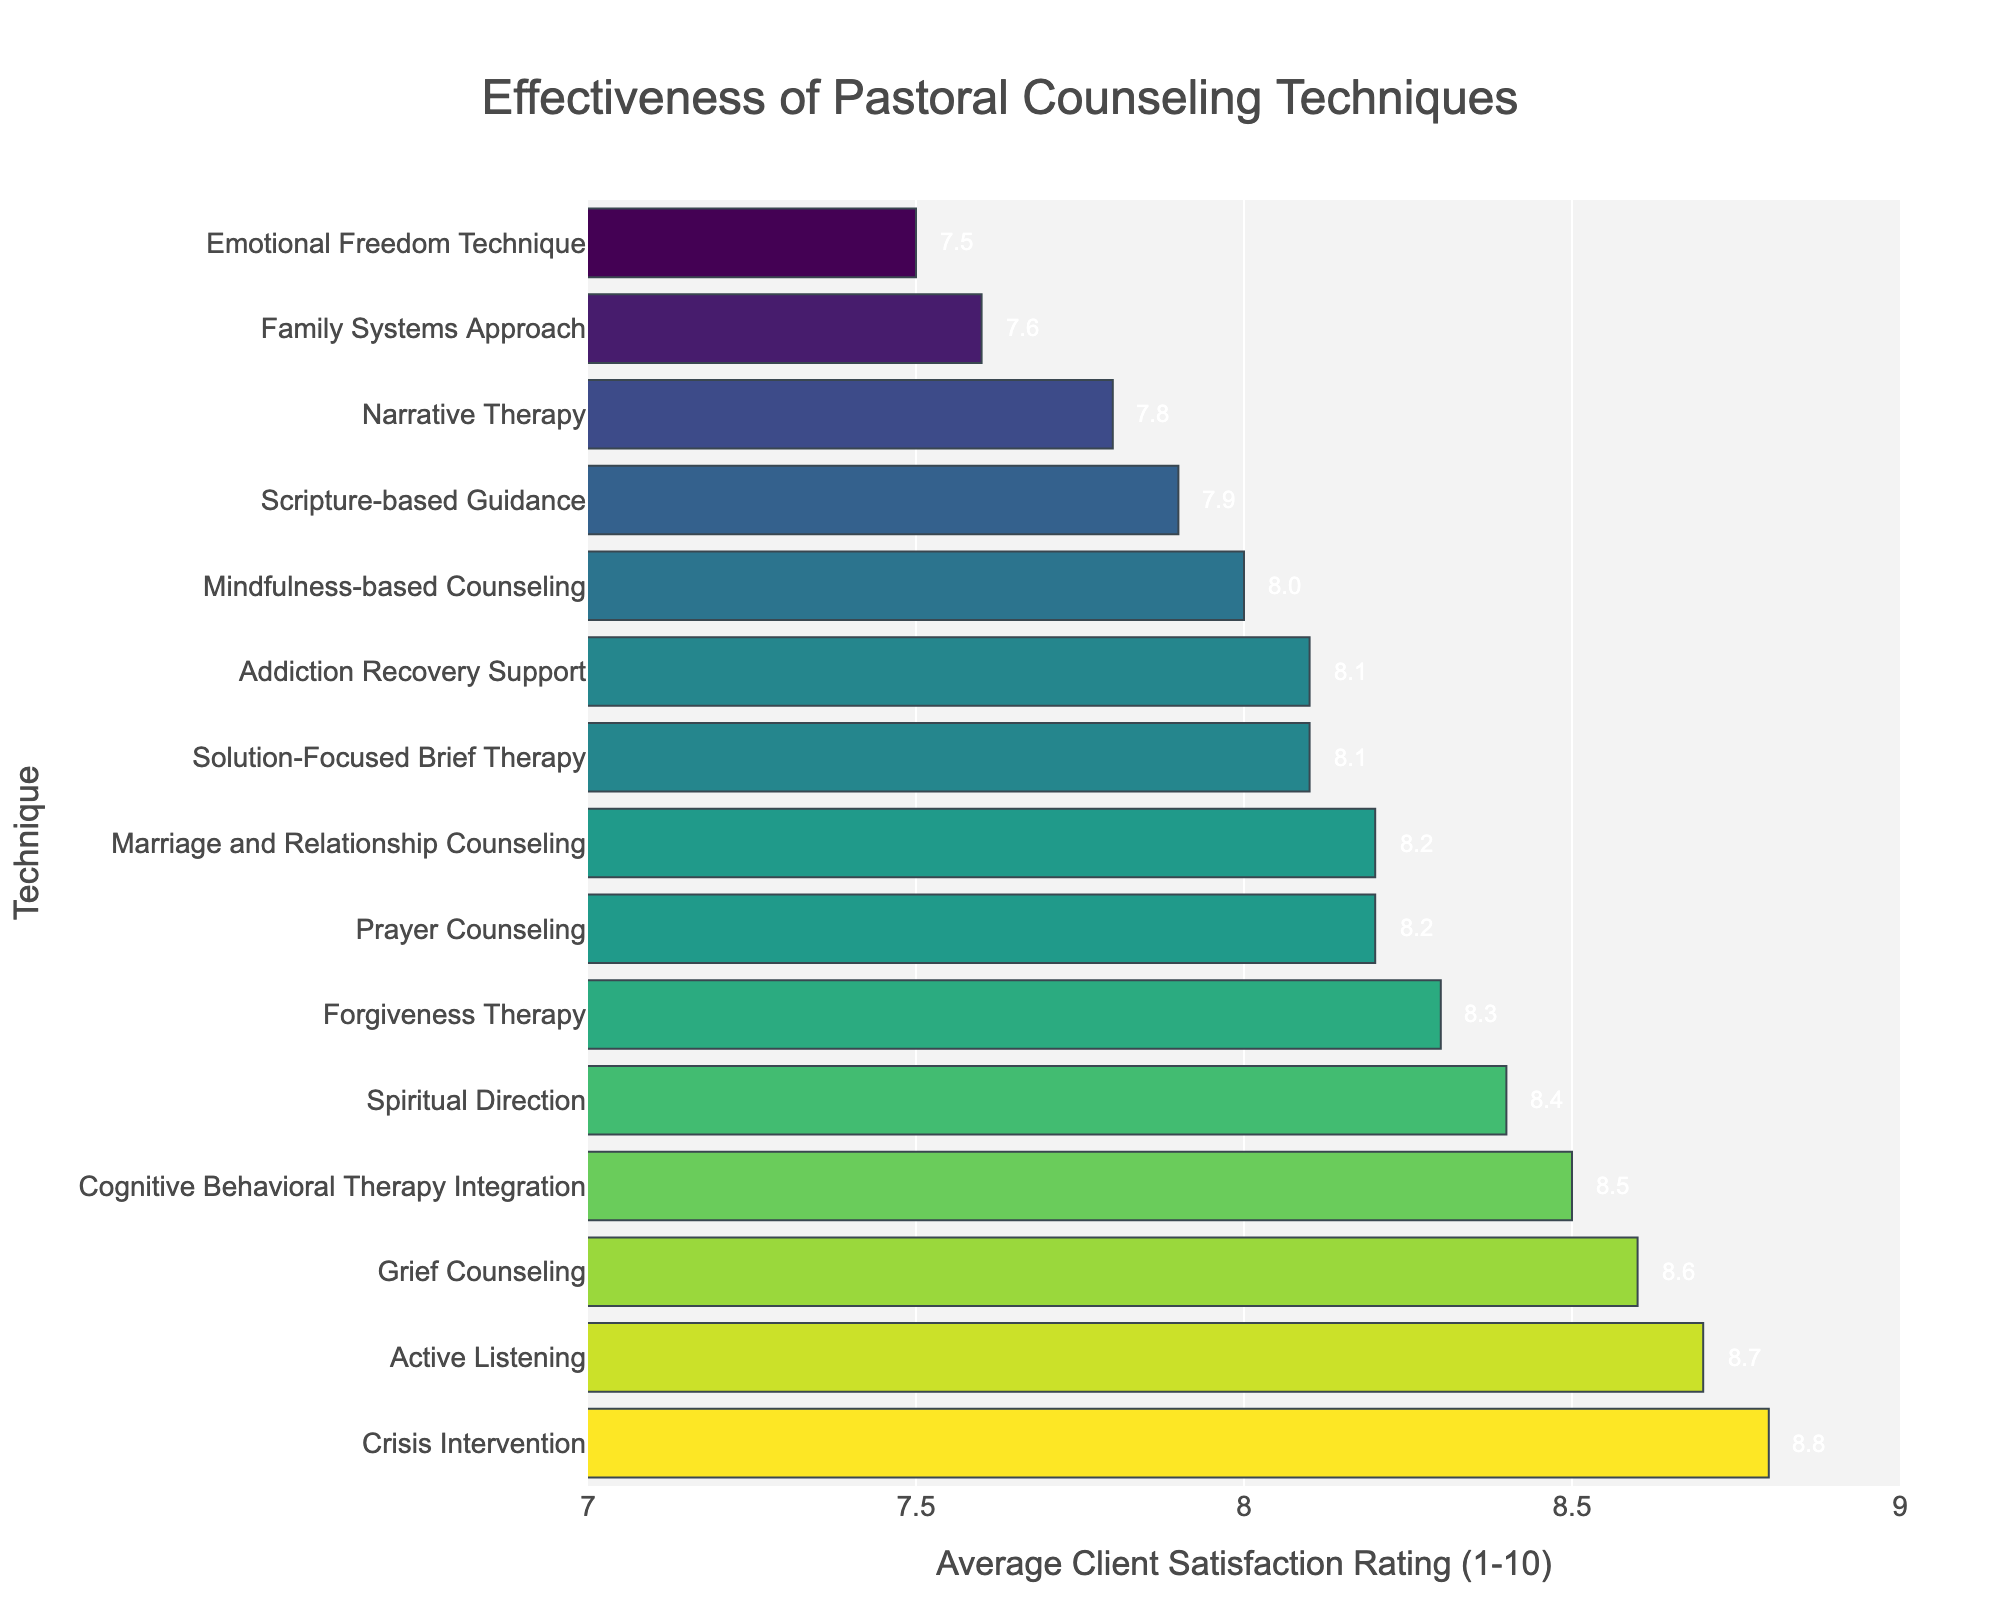What's the highest client satisfaction rating among the pastoral counseling techniques? Look for the bar with the longest length, which represents the highest numerical value. Crisis Intervention has the longest bar with a rating of 8.8.
Answer: 8.8 Which technique has the lowest client satisfaction rating? Find the bar with the shortest length. Emotional Freedom Technique has the shortest bar with a rating of 7.5.
Answer: 7.5 How many counseling techniques have a client satisfaction rating of 8 or higher? Count the number of bars with a length representing a rating of 8 or higher. There are 10 techniques: Active Listening, Prayer Counseling, Cognitive Behavioral Therapy Integration, Solution-Focused Brief Therapy, Forgiveness Therapy, Spiritual Direction, Grief Counseling, Marriage and Relationship Counseling, Crisis Intervention, and Addiction Recovery Support.
Answer: 10 Which technique has a higher client satisfaction rating: Prayer Counseling or Scripture-based Guidance? Compare the bar lengths for Prayer Counseling and Scripture-based Guidance. Prayer Counseling has a rating of 8.2, while Scripture-based Guidance has a rating of 7.9.
Answer: Prayer Counseling What is the difference in client satisfaction ratings between Active Listening and Family Systems Approach? Subtract the rating of Family Systems Approach from the rating of Active Listening. Active Listening has 8.7, and Family Systems Approach has 7.6. The difference is 8.7 - 7.6 = 1.1.
Answer: 1.1 Which techniques have client satisfaction ratings between 8.0 and 8.5? Identify the bars with lengths representing ratings within the range 8.0 to 8.5. Mindfulness-based Counseling (8.0), Solution-Focused Brief Therapy (8.1), Marriage and Relationship Counseling (8.2), Spiritual Direction (8.4), and Cognitive Behavioral Therapy Integration (8.5).
Answer: 5 techniques What is the sum of client satisfaction ratings for Grief Counseling and Family Systems Approach? Add the ratings for Grief Counseling and Family Systems Approach. Grief Counseling has 8.6, and Family Systems Approach has 7.6. The sum is 8.6 + 7.6 = 16.2.
Answer: 16.2 How many techniques have a client satisfaction rating below 8? Count the number of bars with lengths representing ratings below 8. There are 5 techniques: Scripture-based Guidance (7.9), Narrative Therapy (7.8), Family Systems Approach (7.6), and Emotional Freedom Technique (7.5).
Answer: 4 Which technique has a higher client satisfaction rating, Addiction Recovery Support or Solution-Focused Brief Therapy? Compare the bar lengths for Addiction Recovery Support and Solution-Focused Brief Therapy. Both have the same rating of 8.1.
Answer: Both What is the average client satisfaction rating of all the techniques? Add all the ratings together and divide by the total number of techniques (15). The ratings are: 8.7, 7.9, 8.2, 8.5, 7.8, 8.1, 8.3, 7.6, 8.0, 8.4, 8.6, 8.2, 8.8, 8.1, 7.5. The sum is 122.7 and the average is 122.7 / 15 = 8.18.
Answer: 8.18 